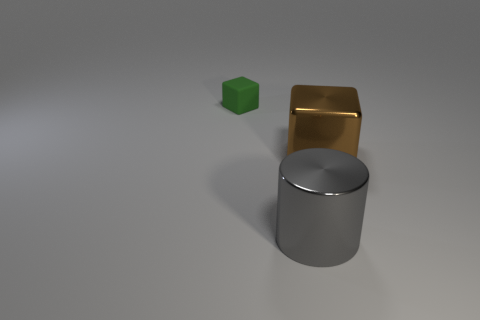Do the cylinder and the shiny cube have the same color?
Give a very brief answer. No. The matte cube has what size?
Your response must be concise. Small. There is a cube that is left of the big shiny thing that is in front of the brown shiny thing; is there a large cube behind it?
Offer a very short reply. No. What shape is the metal thing that is the same size as the shiny cube?
Offer a very short reply. Cylinder. How many tiny things are either red rubber spheres or gray things?
Keep it short and to the point. 0. What is the color of the other large object that is made of the same material as the big brown thing?
Your response must be concise. Gray. There is a thing that is behind the brown cube; does it have the same shape as the large metal thing on the right side of the large gray cylinder?
Your response must be concise. Yes. How many metal objects are either large yellow things or large cubes?
Your answer should be very brief. 1. Is there any other thing that has the same shape as the large gray metallic thing?
Your answer should be compact. No. There is a object that is on the left side of the gray shiny cylinder; what material is it?
Ensure brevity in your answer.  Rubber. 